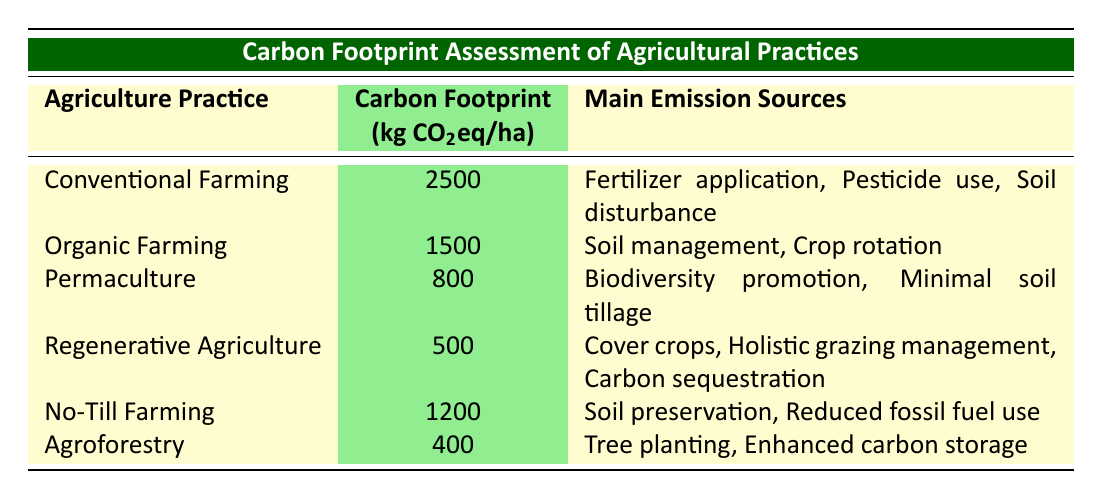What agriculture practice has the highest carbon footprint? The table indicates that Conventional Farming has the highest carbon footprint at 2500 kg CO2eq per hectare.
Answer: Conventional Farming What is the carbon footprint of Agroforestry? According to the table, Agroforestry has a carbon footprint of 400 kg CO2eq per hectare.
Answer: 400 Which agriculture practice has the lowest carbon footprint and what are its main emission sources? The table shows that Regenerative Agriculture has the lowest carbon footprint at 500 kg CO2eq per hectare. Its main emission sources include cover crops, holistic grazing management, and carbon sequestration.
Answer: Regenerative Agriculture; cover crops, holistic grazing management, carbon sequestration What is the difference in carbon footprint between Organic Farming and No-Till Farming? Organic Farming has a carbon footprint of 1500 kg CO2eq per hectare, while No-Till Farming has 1200 kg CO2eq per hectare. The difference is calculated as 1500 - 1200 = 300 kg CO2eq per hectare.
Answer: 300 Are the main emission sources for Permaculture associated with soil management? Yes, one of the main emission sources for Permaculture is biodiversity promotion, and it also states minimal soil tillage, but it does not specifically mention soil management as the only source. Therefore, the statement is somewhat true, as it includes related practices.
Answer: Yes What is the average carbon footprint of the practices listed in the table? The carbon footprints are 2500, 1500, 800, 500, 1200, and 400 kg CO2eq per hectare. Summing these gives 2500 + 1500 + 800 + 500 + 1200 + 400 = 5900. There are 6 data points, so the average is 5900 / 6 = 983.33 kg CO2eq per hectare.
Answer: 983.33 Which agricultural practice has a carbon footprint lower than 1000 kg CO2eq per hectare? The table lists Permaculture at 800 kg CO2eq and Regenerative Agriculture at 500 kg CO2eq as practices with a carbon footprint below 1000 kg CO2eq per hectare.
Answer: Permaculture and Regenerative Agriculture Is No-Till Farming more carbon-intensive than Organic Farming? No-Till Farming has a carbon footprint of 1200 kg CO2eq per hectare, while Organic Farming has a footprint of 1500 kg CO2eq per hectare. Since 1200 is less than 1500, No-Till Farming is not more carbon-intensive than Organic Farming.
Answer: No 